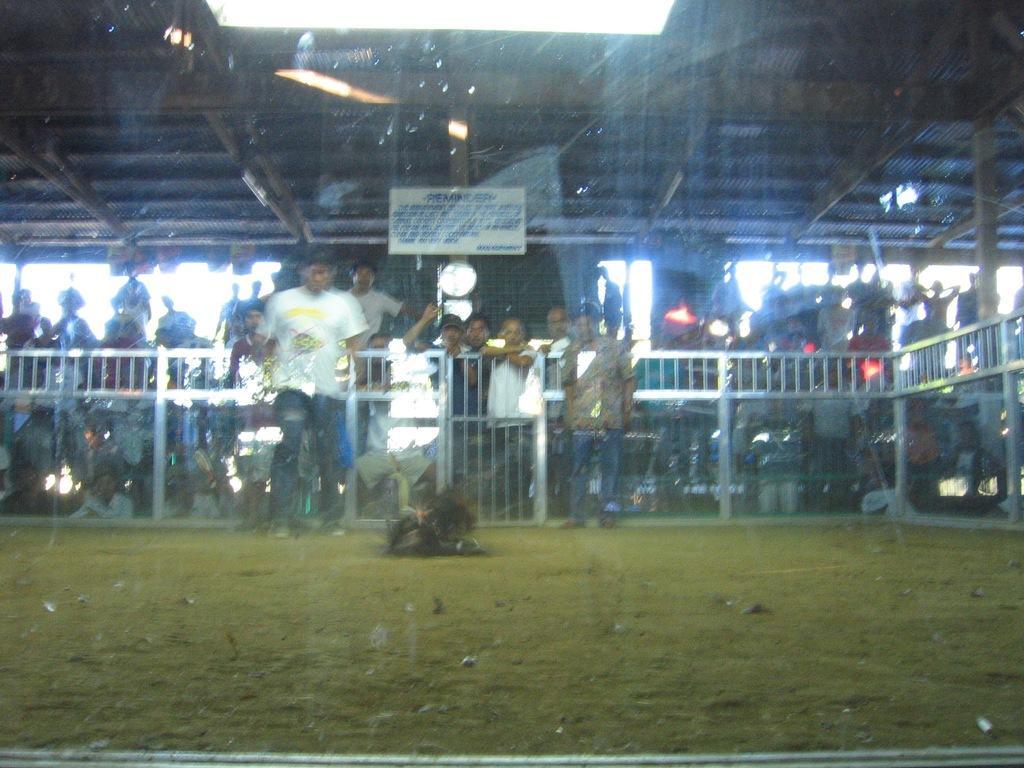Please provide a concise description of this image. In the image we can see there are people standing and there is a bird on the ground. There is grass on the ground and behind there is a hoarding on the top. 